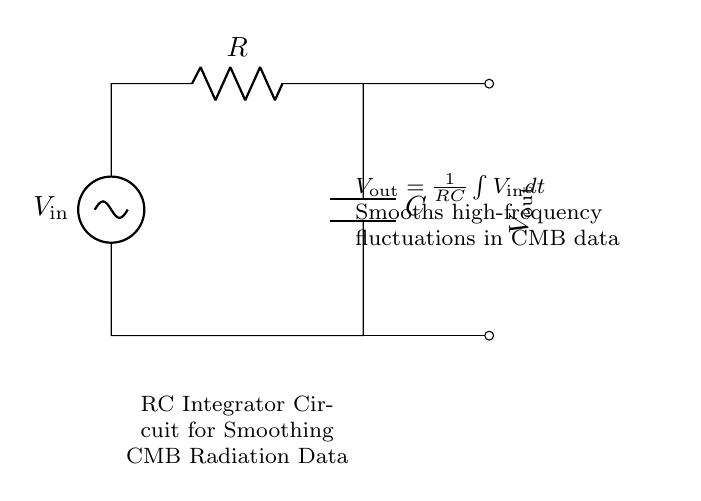What type of circuit is shown? The circuit is an RC integrator circuit, which is specifically designed to integrate the input voltage over time, thus smoothing fluctuations.
Answer: RC integrator circuit What components are present in the circuit? The circuit consists of a resistor and a capacitor connected in series with a voltage source, which are standard components in many electronic circuits.
Answer: Resistor and capacitor What does the output voltage represent in this circuit? The output voltage, represented as V out, is the result of the integration of the input voltage V in with respect to time, indicating how the output smooths the variations in the input signal.
Answer: Integrated input voltage What happens to high-frequency fluctuations in CMB data? The circuit is specifically designed to smooth high-frequency fluctuations in cosmic microwave background radiation data, effectively reducing noise and allowing trends to be observed more clearly.
Answer: They are smoothed out What is the formula for the output voltage in this RC integrator circuit? The output voltage is given by the formula V out equals one over the product of resistance and capacitance times the integral of V in over time, highlighting the relationship between the components and the output signal.
Answer: V out equals one over RC times integral of V in dt What is the function of the resistor in the circuit? The resistor controls the charging and discharging rate of the capacitor, thus influencing the time constant of the circuit, which is crucial for determining how quickly the output responds to changes in input.
Answer: Controls charging rate How does the capacitor affect the circuit operation? The capacitor stores electrical energy and releases it over time, contributing to the circuit's ability to smooth out fluctuations in the input signal by integrating the instantaneous input voltage.
Answer: Stores and integrates voltage 